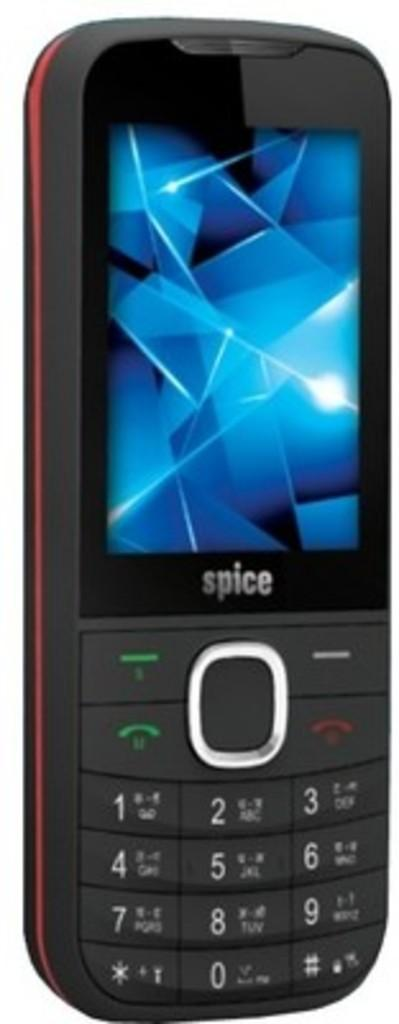<image>
Write a terse but informative summary of the picture. Blue geometric shapes are on the screen of a Spice phone. 